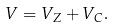Convert formula to latex. <formula><loc_0><loc_0><loc_500><loc_500>V = V _ { Z } + V _ { C } .</formula> 